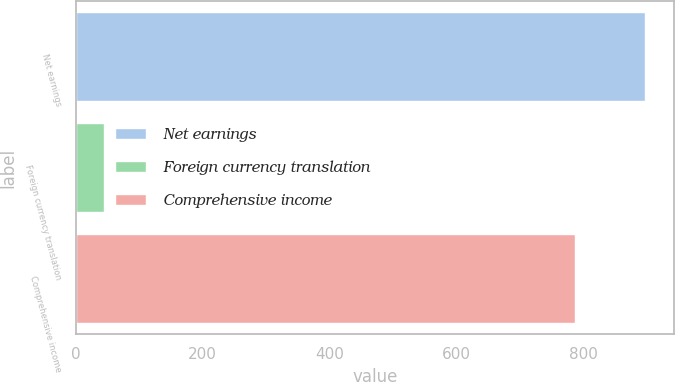<chart> <loc_0><loc_0><loc_500><loc_500><bar_chart><fcel>Net earnings<fcel>Foreign currency translation<fcel>Comprehensive income<nl><fcel>897<fcel>44<fcel>786<nl></chart> 